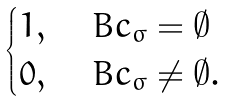<formula> <loc_0><loc_0><loc_500><loc_500>\begin{cases} 1 , & \ B c _ { \sigma } = \emptyset \\ 0 , & \ B c _ { \sigma } \ne \emptyset . \end{cases}</formula> 